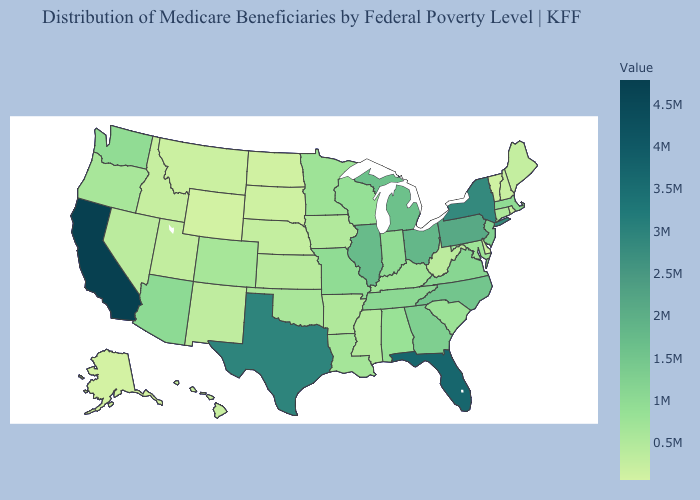Among the states that border Alabama , does Mississippi have the highest value?
Write a very short answer. No. Does the map have missing data?
Give a very brief answer. No. Does the map have missing data?
Short answer required. No. Among the states that border Texas , which have the lowest value?
Concise answer only. New Mexico. Does Florida have the highest value in the South?
Keep it brief. Yes. Does Illinois have the lowest value in the MidWest?
Be succinct. No. 